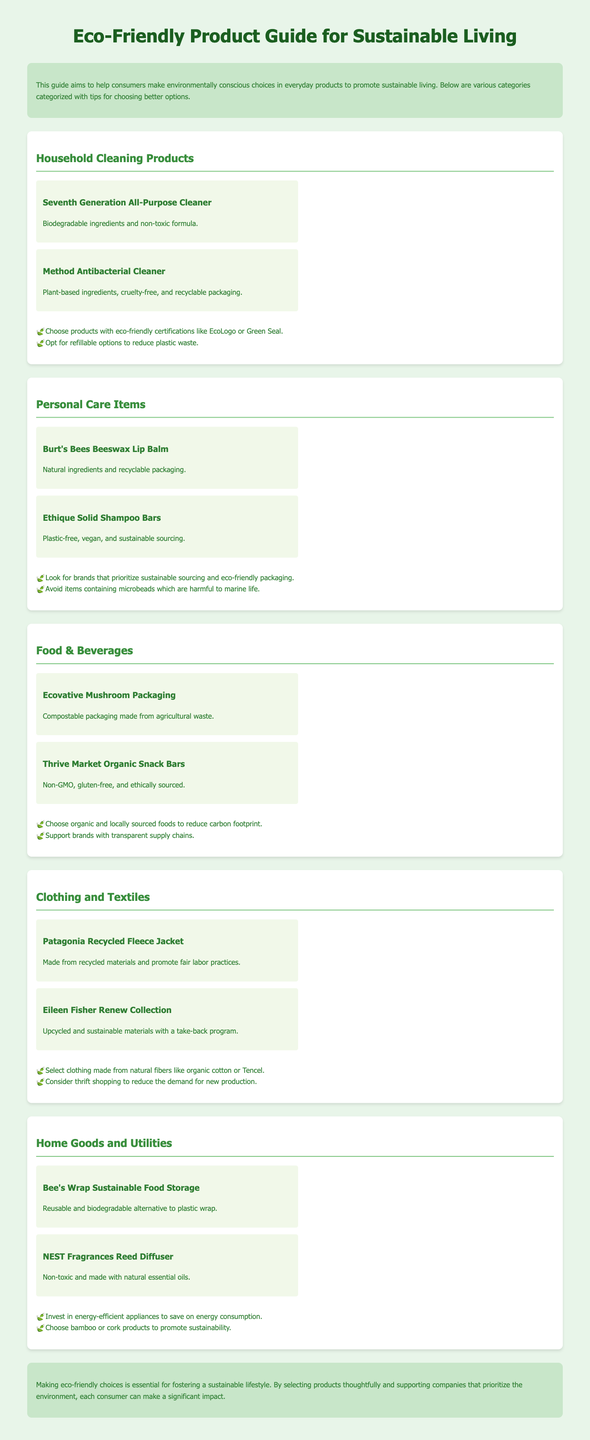what is the title of the guide? The title of the guide is prominently displayed at the top of the document, indicating its purpose.
Answer: Eco-Friendly Product Guide for Sustainable Living how many categories are there in the document? The document lists various categories of eco-friendly products, specifically mentioned in the sections.
Answer: Five name one household cleaning product mentioned. A specific household cleaning product is highlighted with its features for consumers.
Answer: Seventh Generation All-Purpose Cleaner what is a tip for choosing personal care items? One of the tips provided for selecting personal care items emphasizes sustainable practices.
Answer: Look for brands that prioritize sustainable sourcing and eco-friendly packaging which brand offers a recycled fleece jacket? This brand is associated with sustainability and uses recycled materials in one of its products.
Answer: Patagonia what type of packaging is Ecovative Mushroom Packaging made from? The specific material used in the packaging is mentioned to illustrate its eco-friendliness.
Answer: Agricultural waste what is a recommended action to reduce the demand for new production in clothing? This recommendation encourages consumers to adopt a specific shopping practice to be more sustainable.
Answer: Consider thrift shopping how does Bee's Wrap compare to traditional plastic wrap? The document presents this product as a sustainable alternative to a commonly used item.
Answer: Reusable and biodegradable alternative 